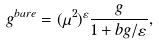<formula> <loc_0><loc_0><loc_500><loc_500>g ^ { b a r e } = ( \mu ^ { 2 } ) ^ { \varepsilon } \frac { g } { 1 + b g / \varepsilon } ,</formula> 